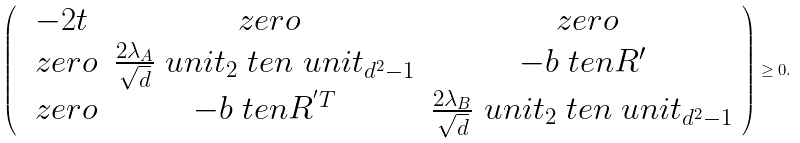<formula> <loc_0><loc_0><loc_500><loc_500>\left ( \begin{array} { c c c } - 2 t & \ z e r o & \ z e r o \\ \ z e r o & \frac { 2 \lambda _ { A } } { \sqrt { d } } \ u n i t _ { 2 } \ t e n \ u n i t _ { d ^ { 2 } - 1 } & - b \ t e n R ^ { \prime } \\ \ z e r o & - b \ t e n R ^ { ^ { \prime } T } & \frac { 2 \lambda _ { B } } { \sqrt { d } } \ u n i t _ { 2 } \ t e n \ u n i t _ { d ^ { 2 } - 1 } \end{array} \right ) \geq 0 .</formula> 